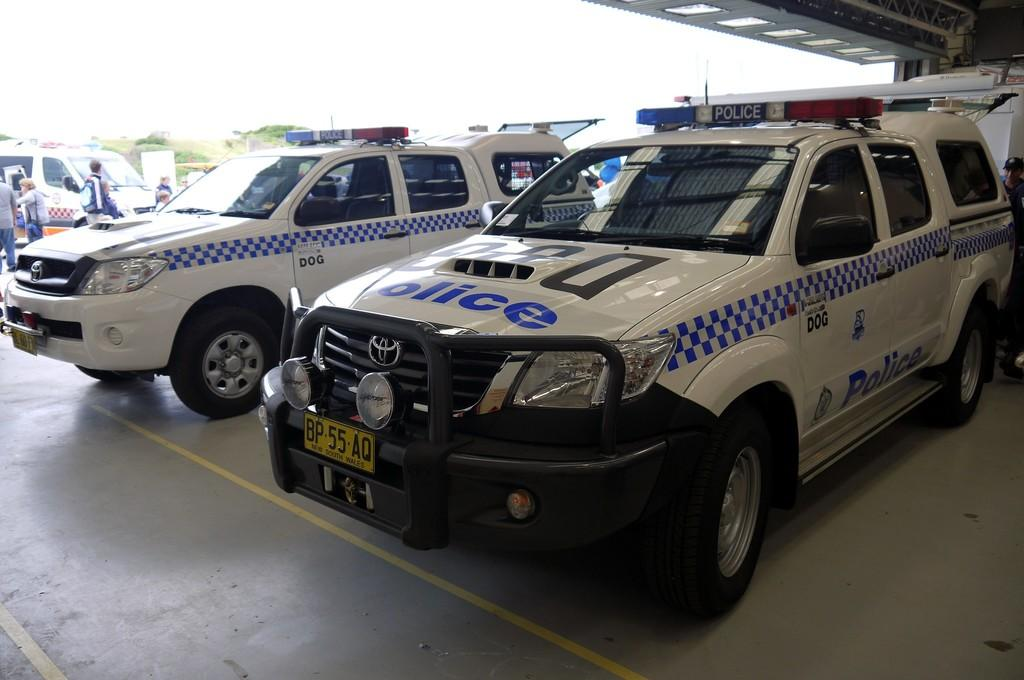What type of vehicles can be seen in the image? There are cars in the image. Who or what else is present in the image? There are people in the image. What can be seen on the ground in the image? There is a path visible in the image. What is visible in the background of the image? The sky is visible in the background of the image. What is written on the cars? There is writing on the cars. What type of sheet is covering the cars in the image? There is no sheet covering the cars in the image. How many bricks are visible on the path in the image? There is no mention of bricks in the image; only a path is visible. 